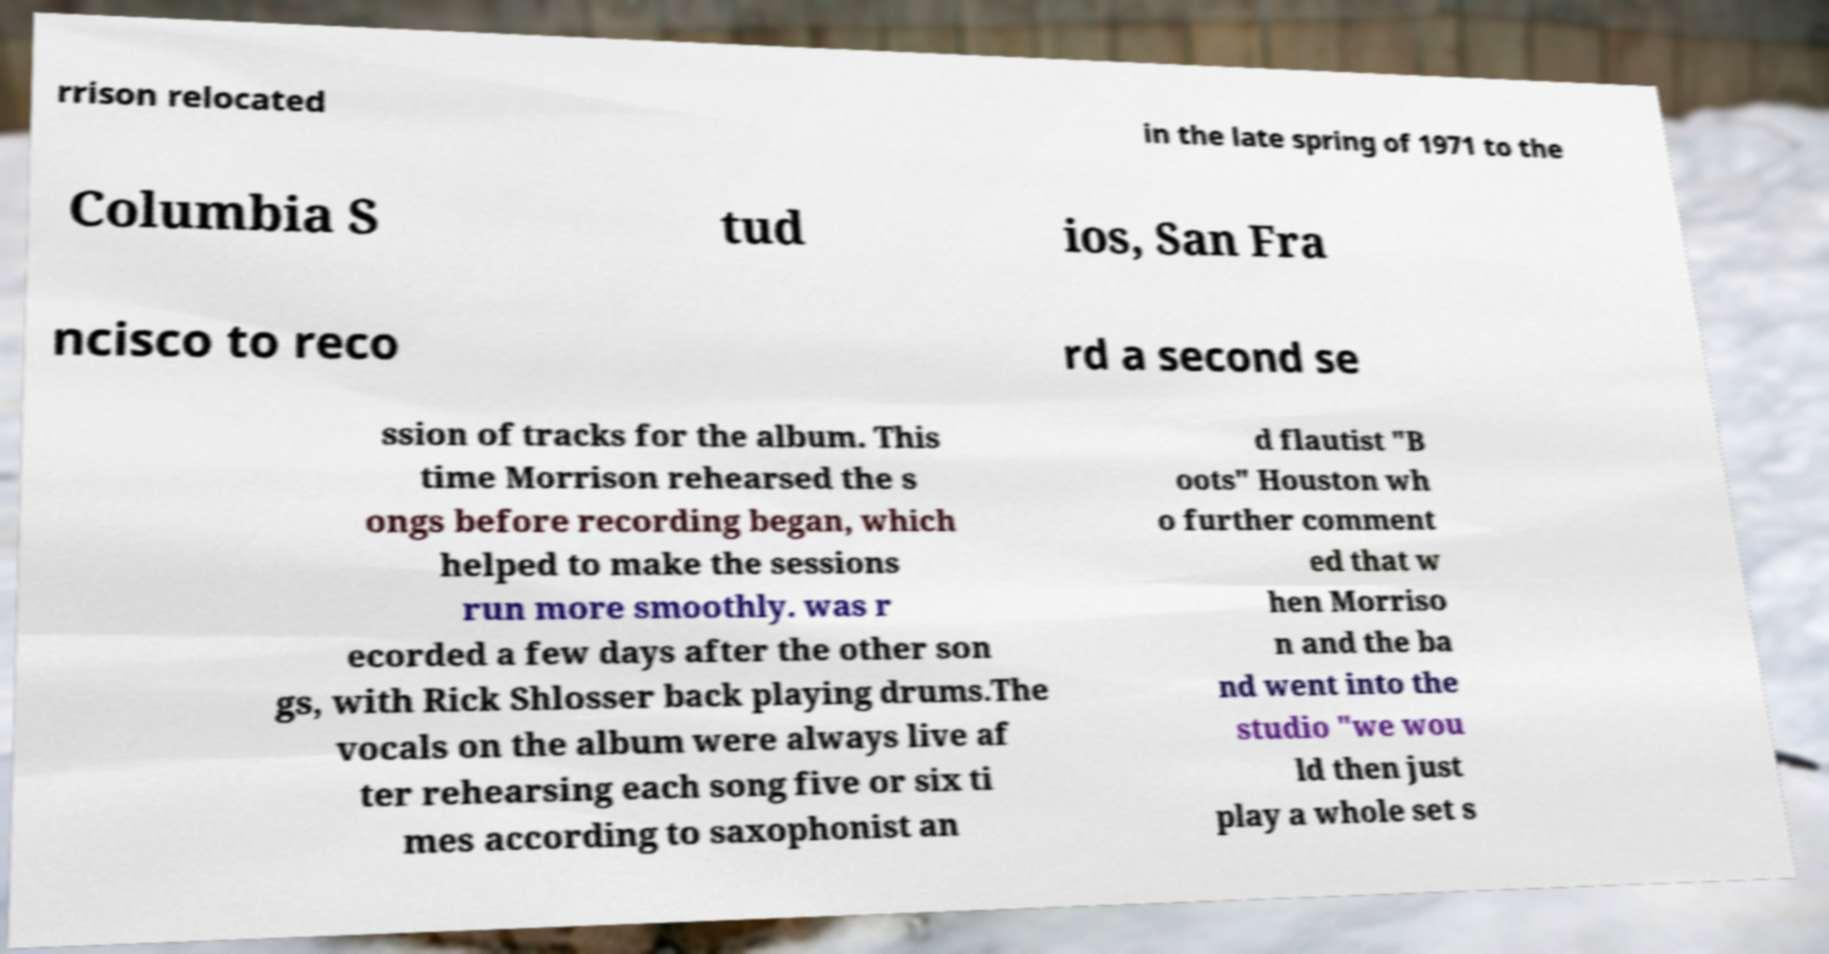Can you read and provide the text displayed in the image?This photo seems to have some interesting text. Can you extract and type it out for me? rrison relocated in the late spring of 1971 to the Columbia S tud ios, San Fra ncisco to reco rd a second se ssion of tracks for the album. This time Morrison rehearsed the s ongs before recording began, which helped to make the sessions run more smoothly. was r ecorded a few days after the other son gs, with Rick Shlosser back playing drums.The vocals on the album were always live af ter rehearsing each song five or six ti mes according to saxophonist an d flautist "B oots" Houston wh o further comment ed that w hen Morriso n and the ba nd went into the studio "we wou ld then just play a whole set s 